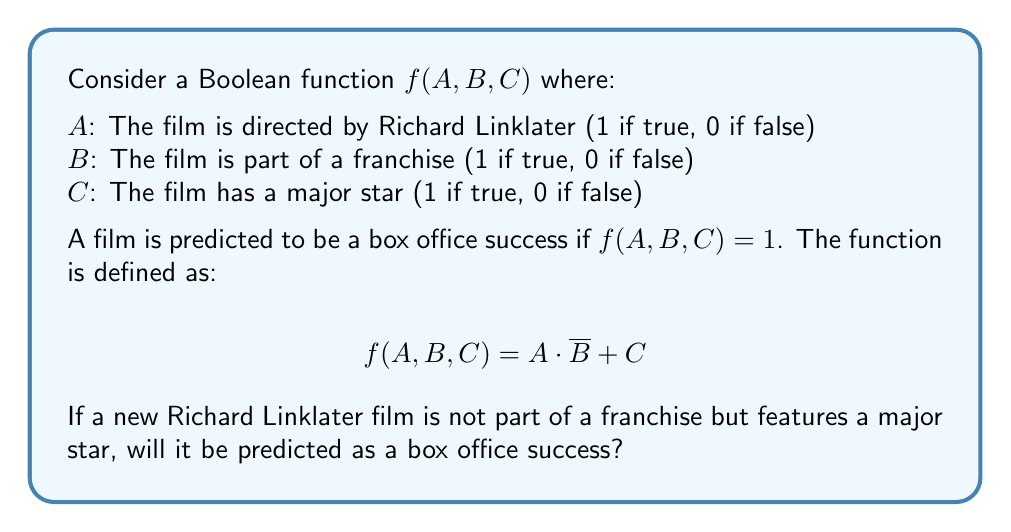Give your solution to this math problem. Let's approach this step-by-step:

1) We are given that the film:
   - Is directed by Richard Linklater, so $A = 1$
   - Is not part of a franchise, so $B = 0$
   - Features a major star, so $C = 1$

2) We need to evaluate $f(A, B, C) = A \cdot \overline{B} + C$

3) First, let's calculate $\overline{B}$:
   $\overline{B} = 1 - B = 1 - 0 = 1$

4) Now, let's substitute the values into the function:
   $f(1, 0, 1) = 1 \cdot 1 + 1$

5) Evaluate:
   $f(1, 0, 1) = 1 + 1 = 2$

6) In Boolean algebra, any non-zero value is considered true (1).

7) Therefore, $f(1, 0, 1) = 1$ in Boolean terms.

Since $f(A, B, C) = 1$, the film is predicted to be a box office success.
Answer: Yes 